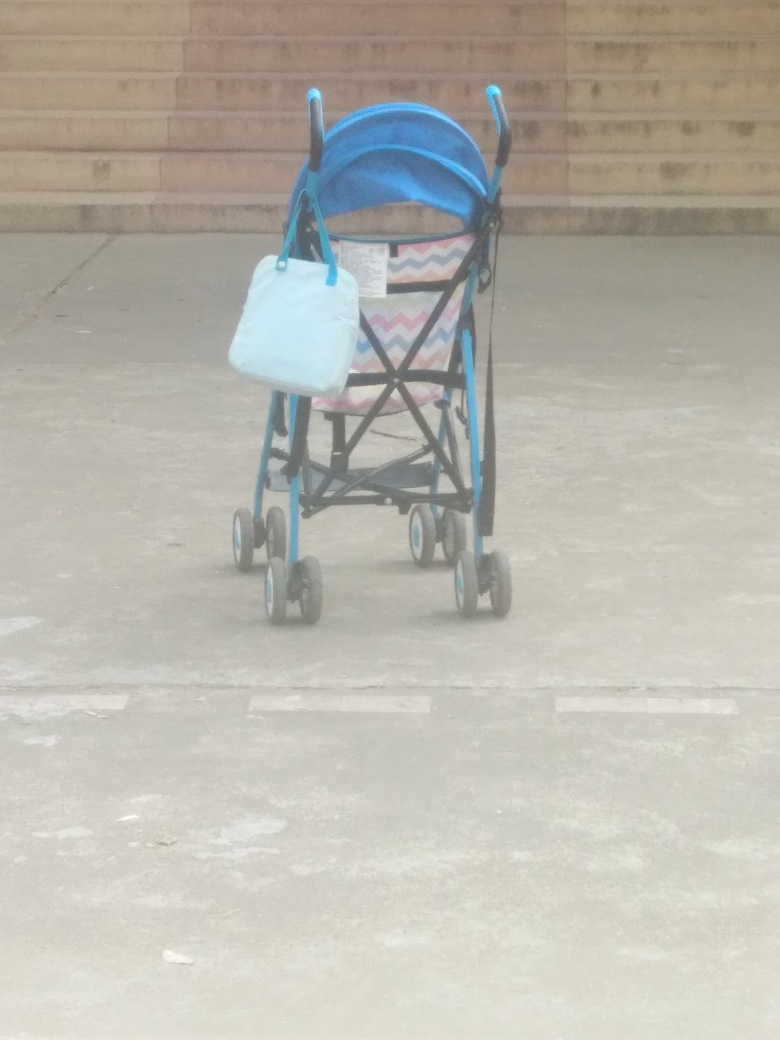What kind of location does this image seem to depict? The image shows a stroller with a bag hanging on it, positioned on a concrete surface, likely outdoors given the daylight and shadow patterns. The background looks like it might be a public place, such as a park or an outdoor area of a shopping complex, hinted by the presence of stairs and what appears to be an open space. Does the image have any items that might suggest the presence of a child or caretaker nearby? A baby stroller is prominently displayed, which usually indicates the presence of a child or baby. However, no child or caretaker is visible in the image, suggesting they might be out of the frame, or the stroller has been momentarily left unattended. The bag hanging on the stroller could belong to the caretaker and suggests that they may be nearby. 